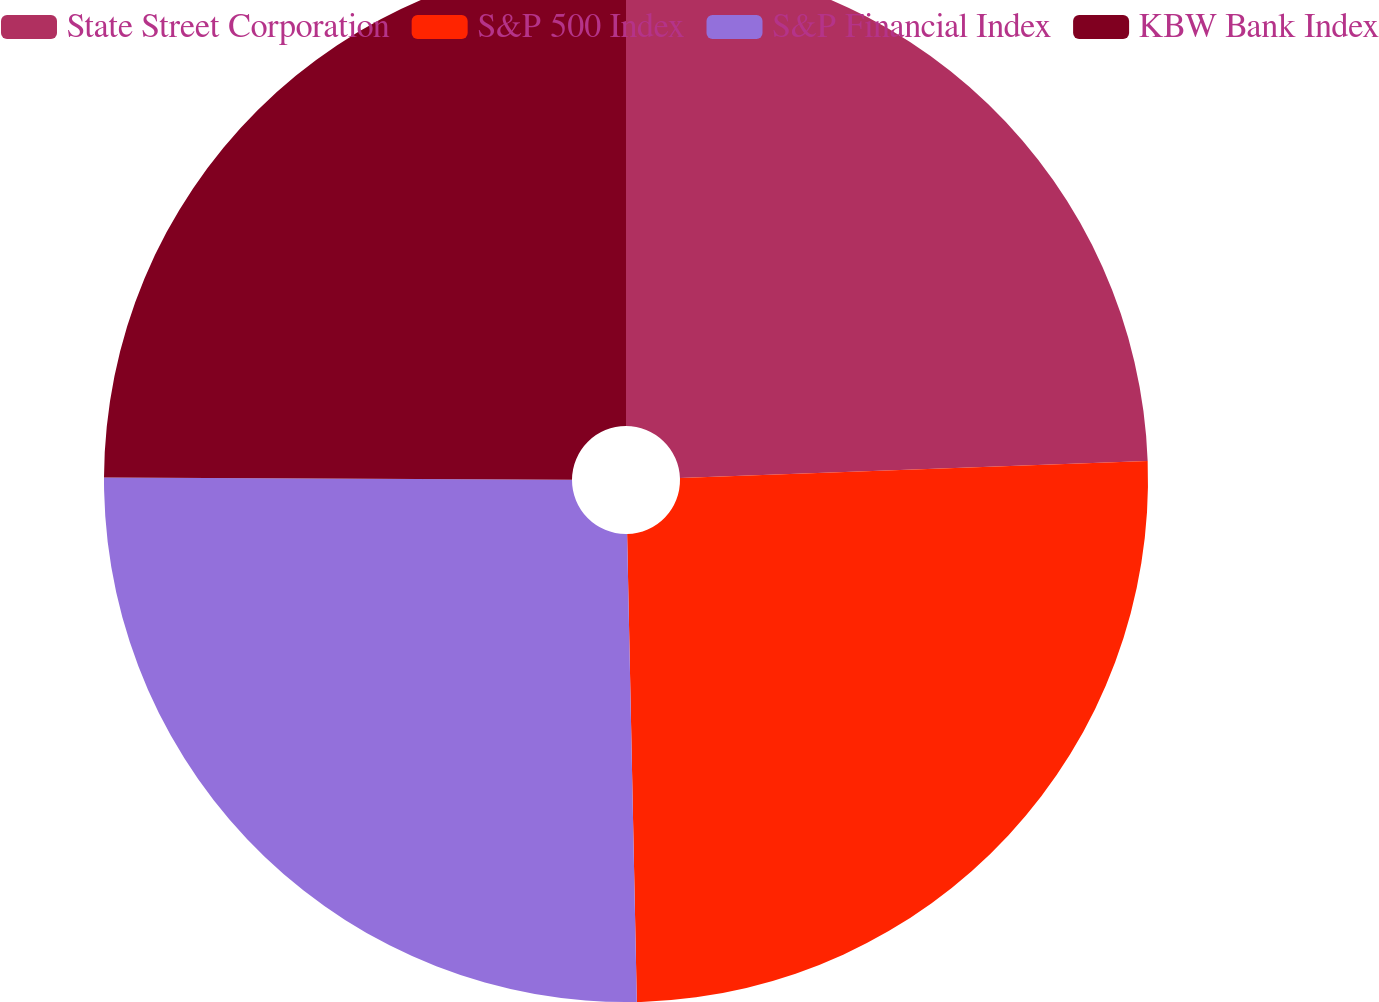Convert chart to OTSL. <chart><loc_0><loc_0><loc_500><loc_500><pie_chart><fcel>State Street Corporation<fcel>S&P 500 Index<fcel>S&P Financial Index<fcel>KBW Bank Index<nl><fcel>24.42%<fcel>25.25%<fcel>25.41%<fcel>24.92%<nl></chart> 